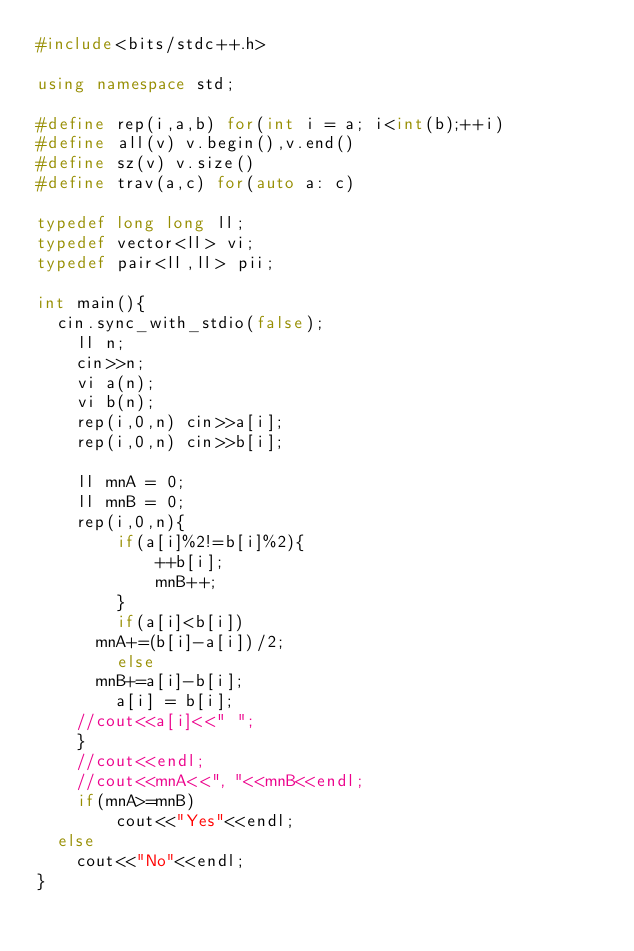<code> <loc_0><loc_0><loc_500><loc_500><_C++_>#include<bits/stdc++.h>

using namespace std;

#define rep(i,a,b) for(int i = a; i<int(b);++i)
#define all(v) v.begin(),v.end()
#define sz(v) v.size()
#define trav(a,c) for(auto a: c)

typedef long long ll;
typedef vector<ll> vi;
typedef pair<ll,ll> pii;

int main(){
	cin.sync_with_stdio(false);
    ll n;
    cin>>n;
    vi a(n);
    vi b(n);
    rep(i,0,n) cin>>a[i];
    rep(i,0,n) cin>>b[i];

    ll mnA = 0;
    ll mnB = 0;
    rep(i,0,n){
        if(a[i]%2!=b[i]%2){
            ++b[i];
            mnB++;
        }
        if(a[i]<b[i])
			mnA+=(b[i]-a[i])/2;
        else
			mnB+=a[i]-b[i];
        a[i] = b[i];
		//cout<<a[i]<<" ";
    }
    //cout<<endl;
    //cout<<mnA<<", "<<mnB<<endl;
    if(mnA>=mnB)
        cout<<"Yes"<<endl;
	else
		cout<<"No"<<endl;
}
</code> 